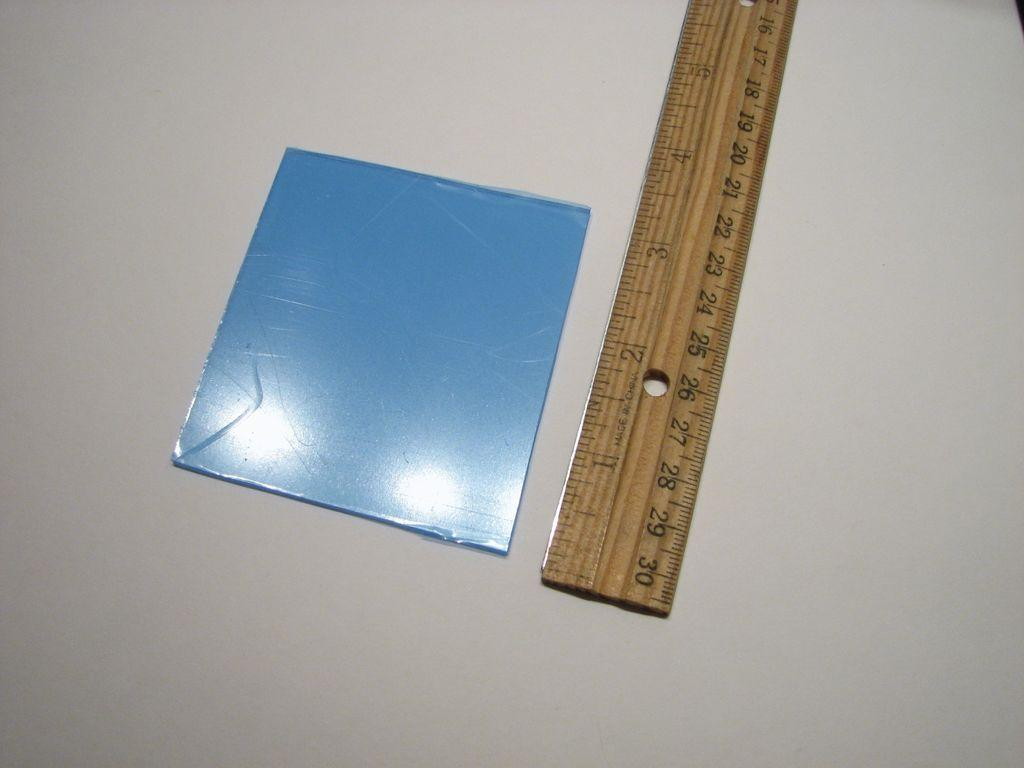What type of object is in the image that can be used for measuring weight? There is a wooden scale in the image. What color is the small object in the image? The small object in the image is blue. What type of furniture is at the bottom of the image? There is a desk at the bottom of the image. What channel is the wooden scale tuned to in the image? The wooden scale is not a television or device that can be tuned to a channel; it is a measuring instrument. What type of beam is supporting the desk in the image? The image does not provide information about the type of beam supporting the desk, if any. 